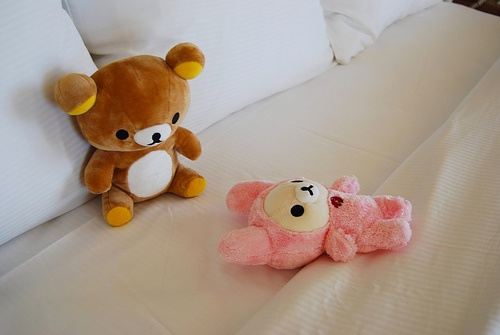Describe the objects in this image and their specific colors. I can see bed in darkgray, tan, lightgray, and salmon tones, teddy bear in darkgray, brown, maroon, and lightgray tones, and teddy bear in darkgray, salmon, lightpink, and tan tones in this image. 